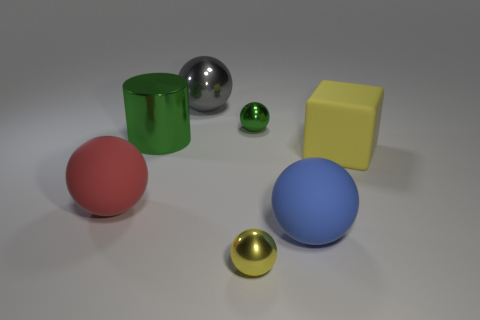How many tiny red cylinders are there?
Make the answer very short. 0. Do the small object to the right of the yellow ball and the large blue ball have the same material?
Keep it short and to the point. No. Is there a red matte block of the same size as the yellow ball?
Provide a succinct answer. No. There is a gray thing; does it have the same shape as the yellow object behind the large blue matte sphere?
Provide a succinct answer. No. Is there a green object that is in front of the small metal ball behind the big matte sphere that is to the left of the large blue thing?
Offer a terse response. Yes. What is the size of the cube?
Make the answer very short. Large. What number of other objects are the same color as the big cylinder?
Offer a very short reply. 1. There is a big shiny object that is to the left of the gray shiny object; is it the same shape as the red matte object?
Your answer should be very brief. No. There is a big shiny thing that is the same shape as the small green thing; what color is it?
Your answer should be very brief. Gray. What size is the green object that is the same shape as the gray object?
Make the answer very short. Small. 